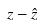<formula> <loc_0><loc_0><loc_500><loc_500>z - \hat { z }</formula> 